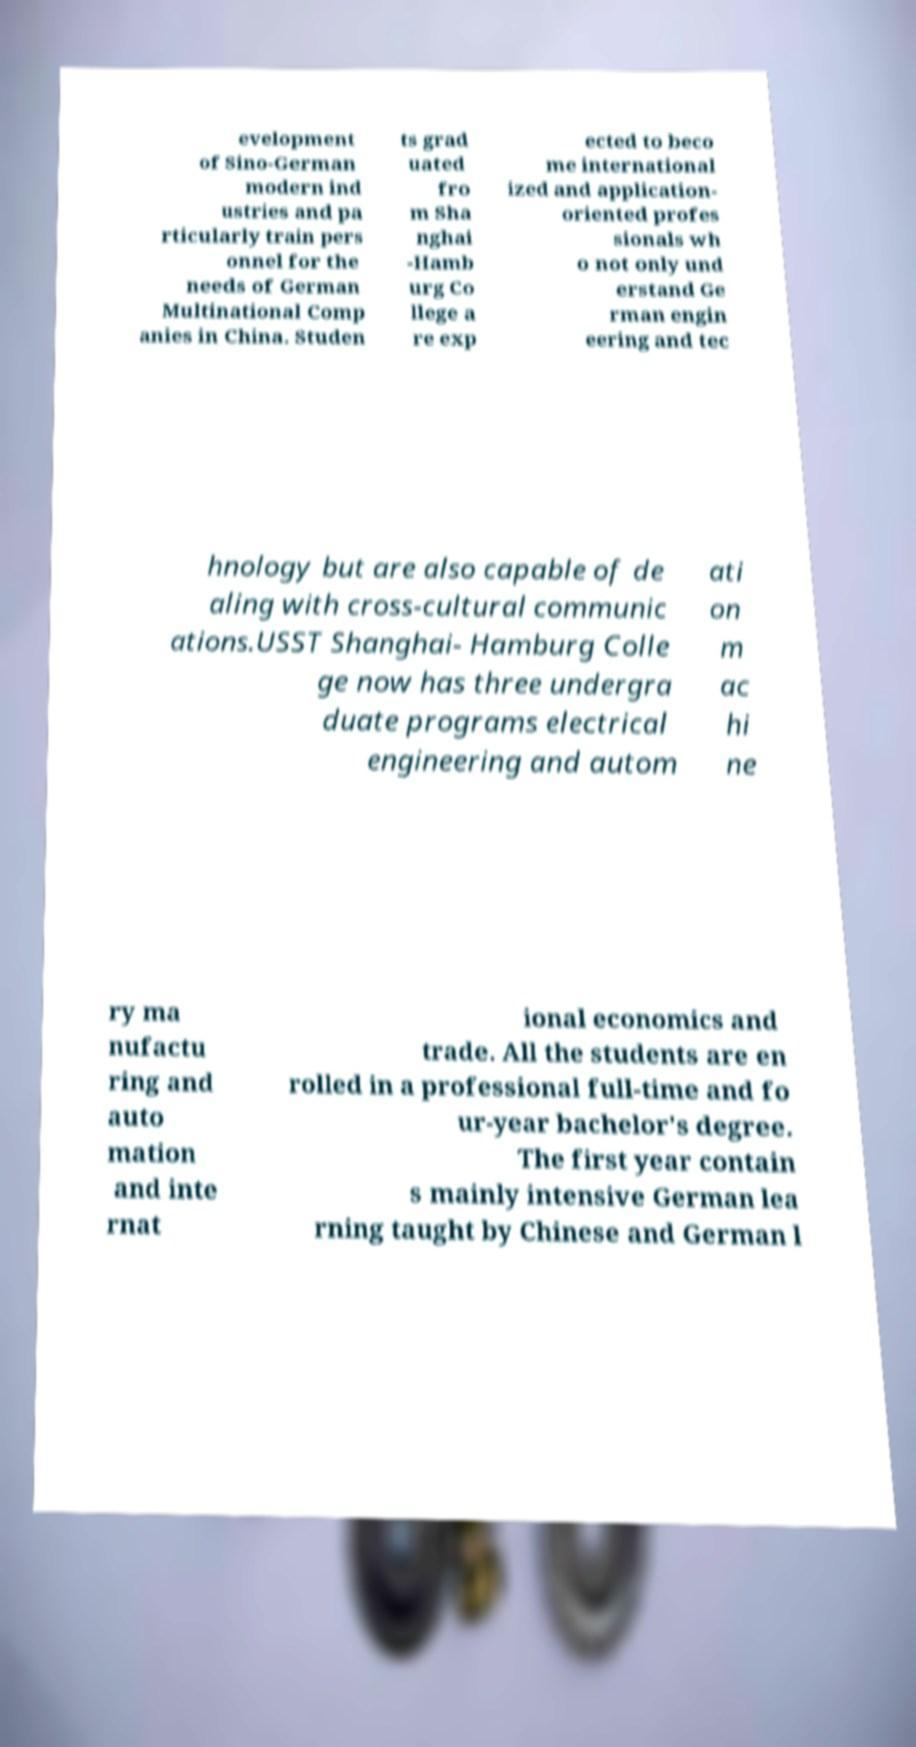Please identify and transcribe the text found in this image. evelopment of Sino-German modern ind ustries and pa rticularly train pers onnel for the needs of German Multinational Comp anies in China. Studen ts grad uated fro m Sha nghai -Hamb urg Co llege a re exp ected to beco me international ized and application- oriented profes sionals wh o not only und erstand Ge rman engin eering and tec hnology but are also capable of de aling with cross-cultural communic ations.USST Shanghai- Hamburg Colle ge now has three undergra duate programs electrical engineering and autom ati on m ac hi ne ry ma nufactu ring and auto mation and inte rnat ional economics and trade. All the students are en rolled in a professional full-time and fo ur-year bachelor's degree. The first year contain s mainly intensive German lea rning taught by Chinese and German l 